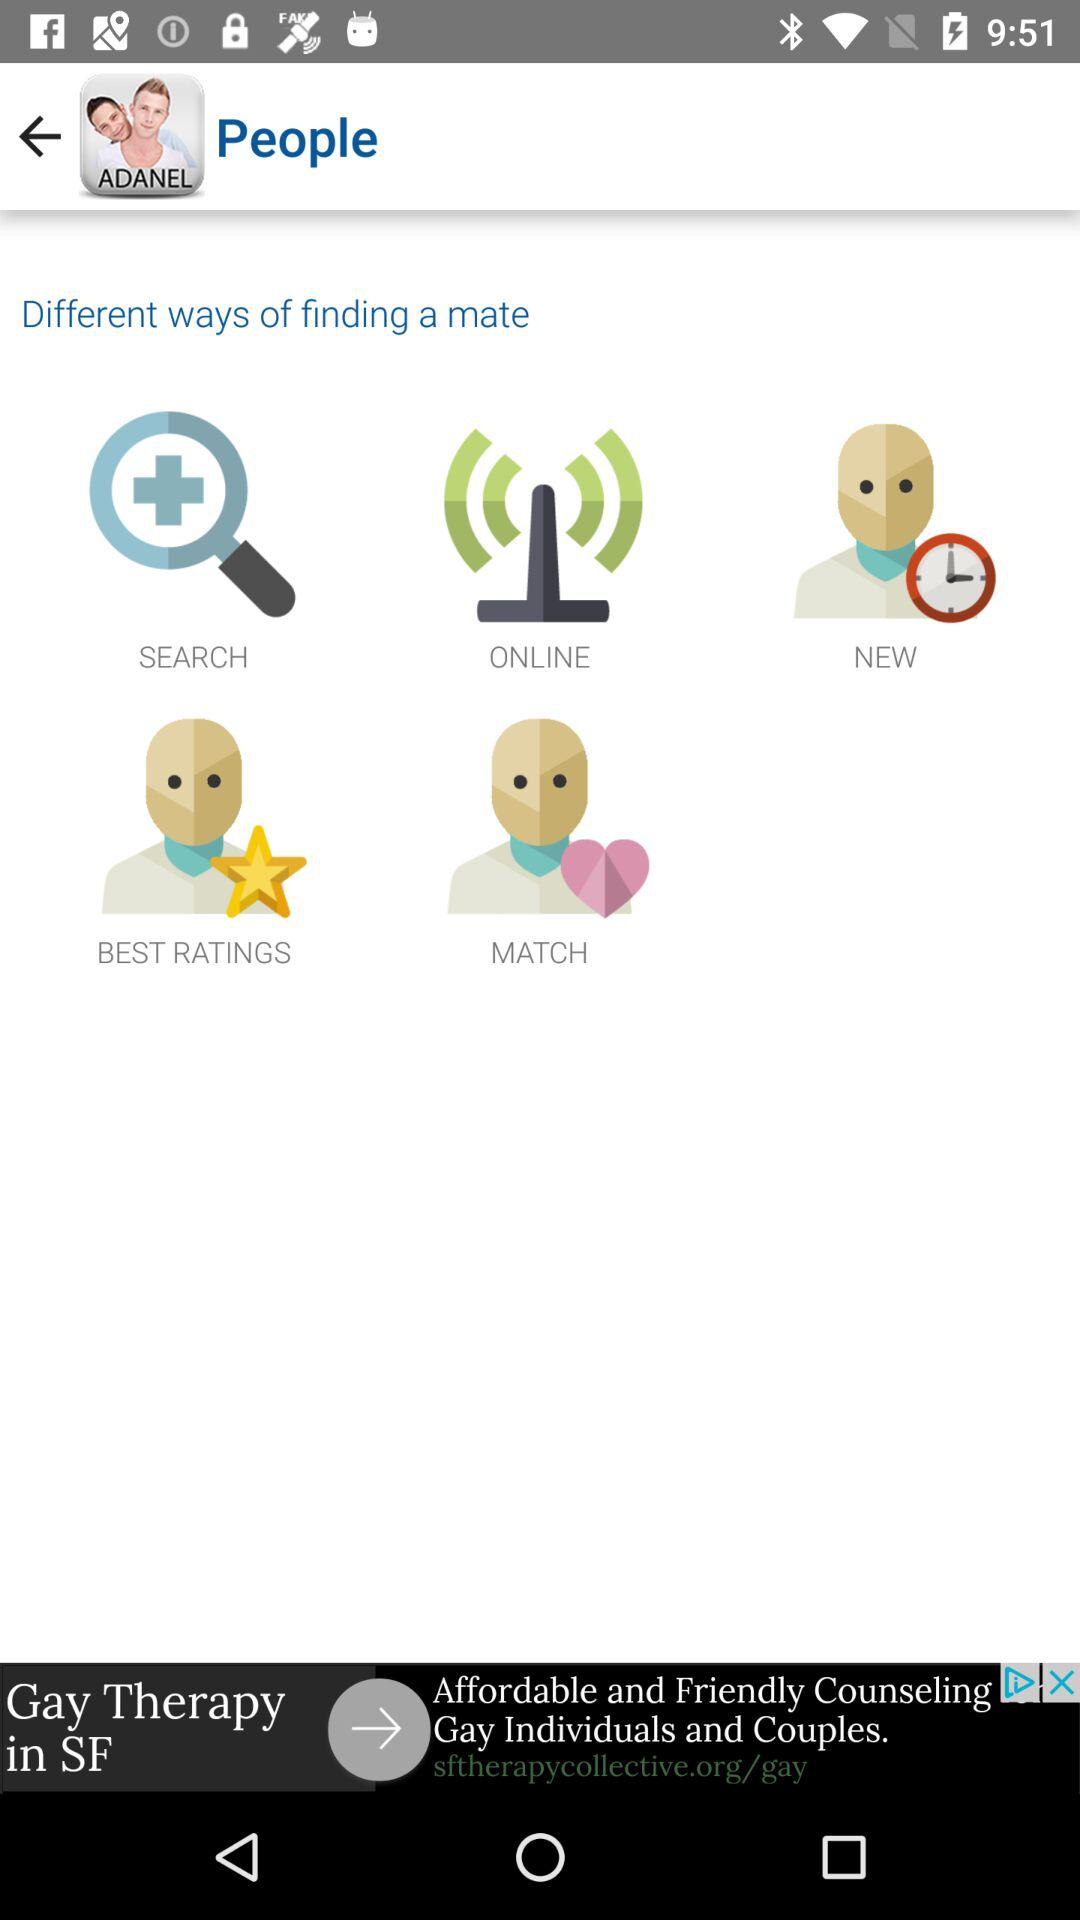What are the different ways of finding a mate? The different ways of finding a mate are "SEARCH", "ONLINE", "NEW", "BEST RATINGS" and "MATCH". 